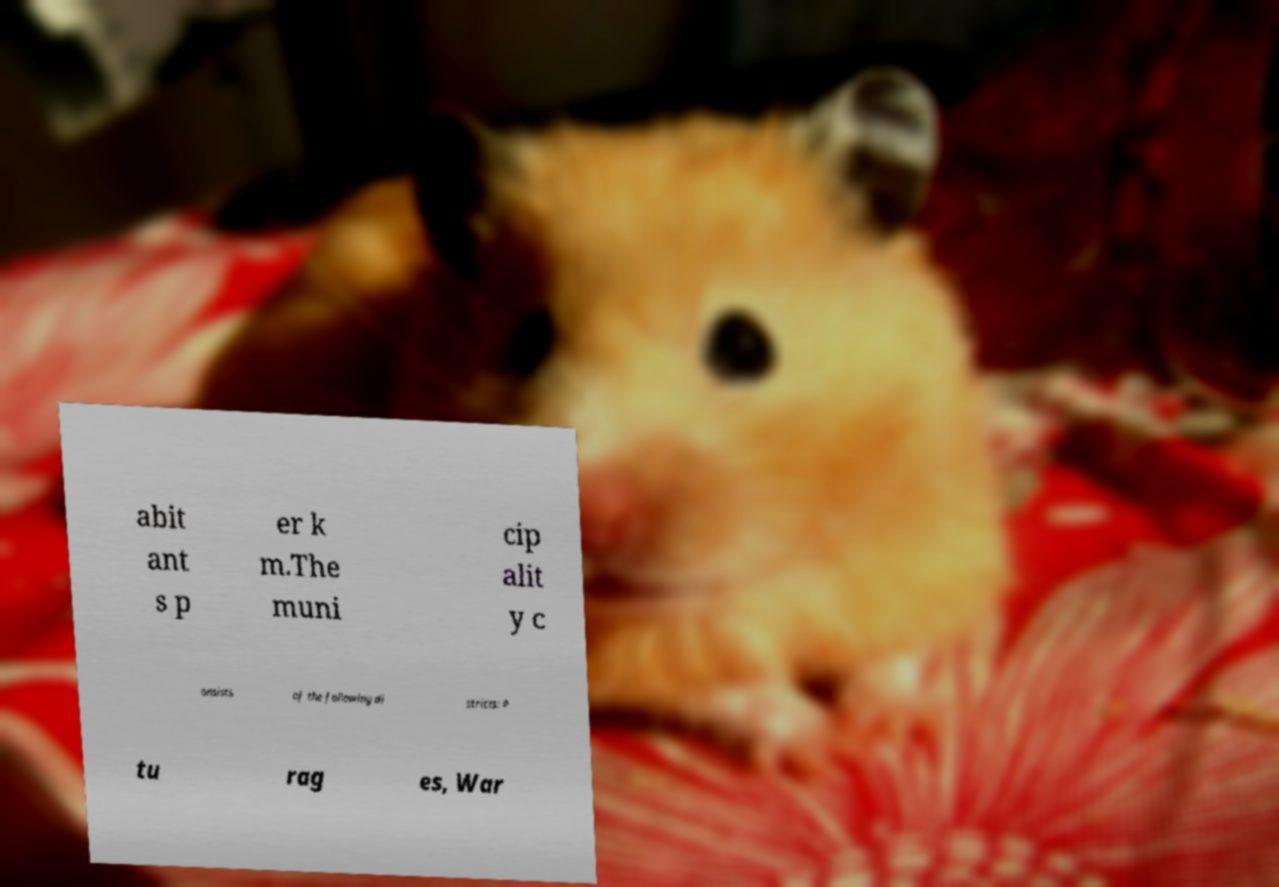Please identify and transcribe the text found in this image. abit ant s p er k m.The muni cip alit y c onsists of the following di stricts: P tu rag es, War 